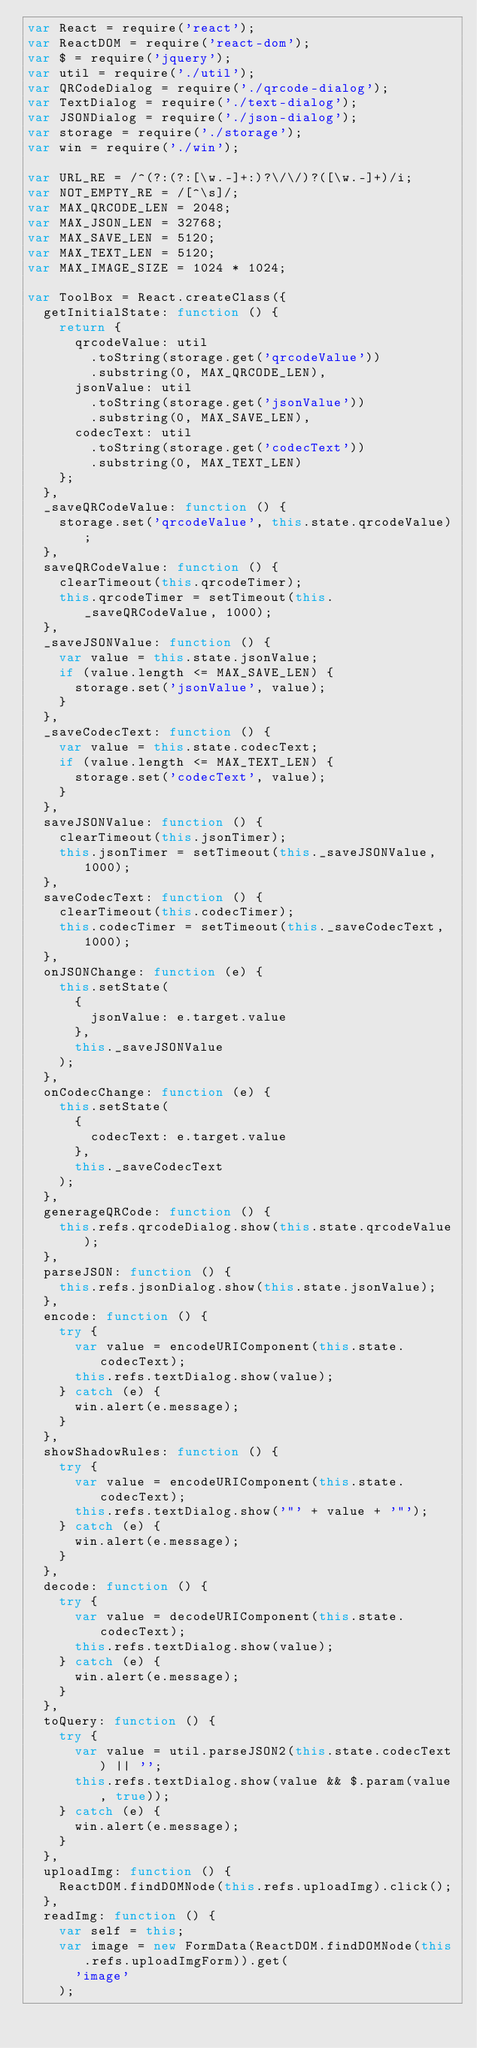<code> <loc_0><loc_0><loc_500><loc_500><_JavaScript_>var React = require('react');
var ReactDOM = require('react-dom');
var $ = require('jquery');
var util = require('./util');
var QRCodeDialog = require('./qrcode-dialog');
var TextDialog = require('./text-dialog');
var JSONDialog = require('./json-dialog');
var storage = require('./storage');
var win = require('./win');

var URL_RE = /^(?:(?:[\w.-]+:)?\/\/)?([\w.-]+)/i;
var NOT_EMPTY_RE = /[^\s]/;
var MAX_QRCODE_LEN = 2048;
var MAX_JSON_LEN = 32768;
var MAX_SAVE_LEN = 5120;
var MAX_TEXT_LEN = 5120;
var MAX_IMAGE_SIZE = 1024 * 1024;

var ToolBox = React.createClass({
  getInitialState: function () {
    return {
      qrcodeValue: util
        .toString(storage.get('qrcodeValue'))
        .substring(0, MAX_QRCODE_LEN),
      jsonValue: util
        .toString(storage.get('jsonValue'))
        .substring(0, MAX_SAVE_LEN),
      codecText: util
        .toString(storage.get('codecText'))
        .substring(0, MAX_TEXT_LEN)
    };
  },
  _saveQRCodeValue: function () {
    storage.set('qrcodeValue', this.state.qrcodeValue);
  },
  saveQRCodeValue: function () {
    clearTimeout(this.qrcodeTimer);
    this.qrcodeTimer = setTimeout(this._saveQRCodeValue, 1000);
  },
  _saveJSONValue: function () {
    var value = this.state.jsonValue;
    if (value.length <= MAX_SAVE_LEN) {
      storage.set('jsonValue', value);
    }
  },
  _saveCodecText: function () {
    var value = this.state.codecText;
    if (value.length <= MAX_TEXT_LEN) {
      storage.set('codecText', value);
    }
  },
  saveJSONValue: function () {
    clearTimeout(this.jsonTimer);
    this.jsonTimer = setTimeout(this._saveJSONValue, 1000);
  },
  saveCodecText: function () {
    clearTimeout(this.codecTimer);
    this.codecTimer = setTimeout(this._saveCodecText, 1000);
  },
  onJSONChange: function (e) {
    this.setState(
      {
        jsonValue: e.target.value
      },
      this._saveJSONValue
    );
  },
  onCodecChange: function (e) {
    this.setState(
      {
        codecText: e.target.value
      },
      this._saveCodecText
    );
  },
  generageQRCode: function () {
    this.refs.qrcodeDialog.show(this.state.qrcodeValue);
  },
  parseJSON: function () {
    this.refs.jsonDialog.show(this.state.jsonValue);
  },
  encode: function () {
    try {
      var value = encodeURIComponent(this.state.codecText);
      this.refs.textDialog.show(value);
    } catch (e) {
      win.alert(e.message);
    }
  },
  showShadowRules: function () {
    try {
      var value = encodeURIComponent(this.state.codecText);
      this.refs.textDialog.show('"' + value + '"');
    } catch (e) {
      win.alert(e.message);
    }
  },
  decode: function () {
    try {
      var value = decodeURIComponent(this.state.codecText);
      this.refs.textDialog.show(value);
    } catch (e) {
      win.alert(e.message);
    }
  },
  toQuery: function () {
    try {
      var value = util.parseJSON2(this.state.codecText) || '';
      this.refs.textDialog.show(value && $.param(value, true));
    } catch (e) {
      win.alert(e.message);
    }
  },
  uploadImg: function () {
    ReactDOM.findDOMNode(this.refs.uploadImg).click();
  },
  readImg: function () {
    var self = this;
    var image = new FormData(ReactDOM.findDOMNode(this.refs.uploadImgForm)).get(
      'image'
    );</code> 